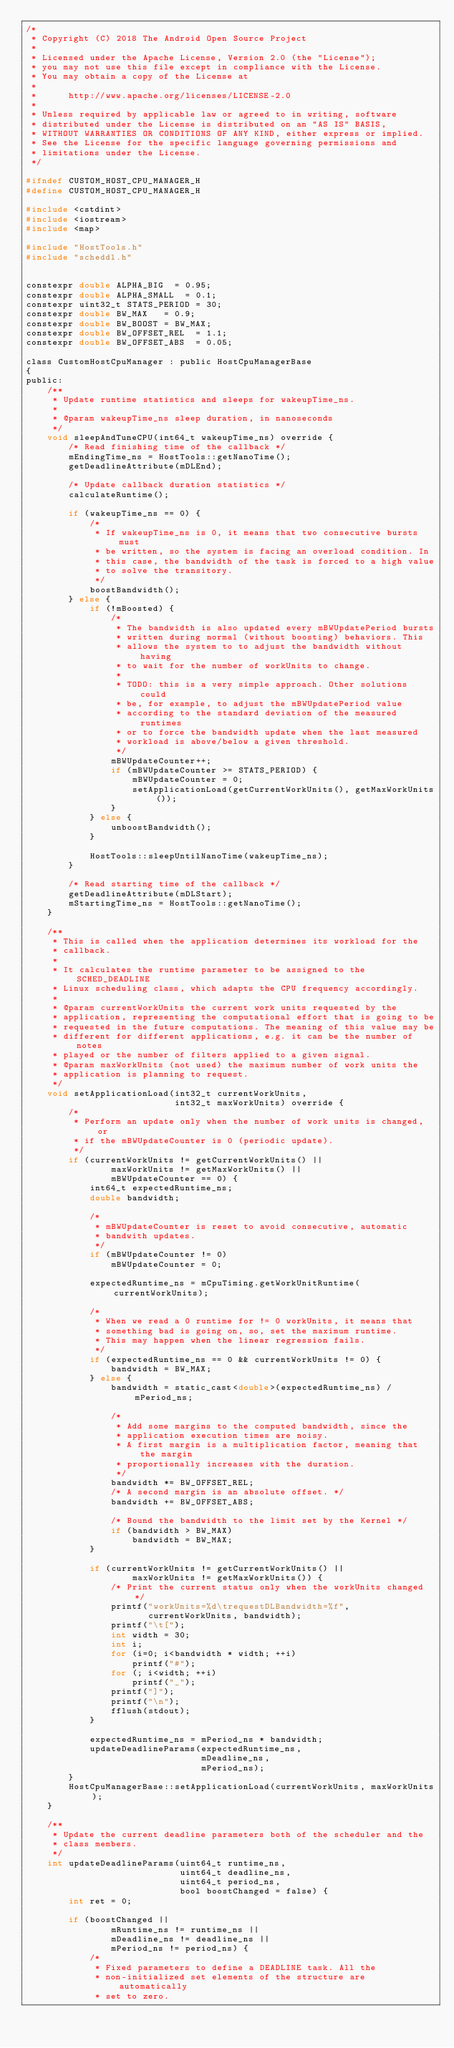Convert code to text. <code><loc_0><loc_0><loc_500><loc_500><_C_>/*
 * Copyright (C) 2018 The Android Open Source Project
 *
 * Licensed under the Apache License, Version 2.0 (the "License");
 * you may not use this file except in compliance with the License.
 * You may obtain a copy of the License at
 *
 *      http://www.apache.org/licenses/LICENSE-2.0
 *
 * Unless required by applicable law or agreed to in writing, software
 * distributed under the License is distributed on an "AS IS" BASIS,
 * WITHOUT WARRANTIES OR CONDITIONS OF ANY KIND, either express or implied.
 * See the License for the specific language governing permissions and
 * limitations under the License.
 */

#ifndef CUSTOM_HOST_CPU_MANAGER_H
#define CUSTOM_HOST_CPU_MANAGER_H

#include <cstdint>
#include <iostream>
#include <map>

#include "HostTools.h"
#include "scheddl.h"


constexpr double ALPHA_BIG	= 0.95;
constexpr double ALPHA_SMALL	= 0.1;
constexpr uint32_t STATS_PERIOD	= 30;
constexpr double BW_MAX		= 0.9;
constexpr double BW_BOOST	= BW_MAX;
constexpr double BW_OFFSET_REL	= 1.1;
constexpr double BW_OFFSET_ABS	= 0.05;

class CustomHostCpuManager : public HostCpuManagerBase
{
public:
    /**
     * Update runtime statistics and sleeps for wakeupTime_ns.
     *
     * @param wakeupTime_ns sleep duration, in nanoseconds
     */
    void sleepAndTuneCPU(int64_t wakeupTime_ns) override {
        /* Read finishing time of the callback */
        mEndingTime_ns = HostTools::getNanoTime();
        getDeadlineAttribute(mDLEnd);

        /* Update callback duration statistics */
        calculateRuntime();

        if (wakeupTime_ns == 0) {
            /*
             * If wakeupTime_ns is 0, it means that two consecutive bursts must
             * be written, so the system is facing an overload condition. In
             * this case, the bandwidth of the task is forced to a high value
             * to solve the transitory.
             */
            boostBandwidth();
        } else {
            if (!mBoosted) {
                /*
                 * The bandwidth is also updated every mBWUpdatePeriod bursts
                 * written during normal (without boosting) behaviors. This
                 * allows the system to to adjust the bandwidth without having
                 * to wait for the number of workUnits to change.
                 *
                 * TODO: this is a very simple approach. Other solutions could
                 * be, for example, to adjust the mBWUpdatePeriod value
                 * according to the standard deviation of the measured runtimes
                 * or to force the bandwidth update when the last measured
                 * workload is above/below a given threshold.
                 */
                mBWUpdateCounter++;
                if (mBWUpdateCounter >= STATS_PERIOD) {
                    mBWUpdateCounter = 0;
                    setApplicationLoad(getCurrentWorkUnits(), getMaxWorkUnits());
                }
            } else {
                unboostBandwidth();
            }

            HostTools::sleepUntilNanoTime(wakeupTime_ns);
        }

        /* Read starting time of the callback */
        getDeadlineAttribute(mDLStart);
        mStartingTime_ns = HostTools::getNanoTime();
    }

    /**
     * This is called when the application determines its workload for the
     * callback.
     *
     * It calculates the runtime parameter to be assigned to the SCHED_DEADLINE
     * Linux scheduling class, which adapts the CPU frequency accordingly.
     *
     * @param currentWorkUnits the current work units requested by the
     * application, representing the computational effort that is going to be
     * requested in the future computations. The meaning of this value may be
     * different for different applications, e.g. it can be the number of notes
     * played or the number of filters applied to a given signal.
     * @param maxWorkUnits (not used) the maximum number of work units the
     * application is planning to request.
     */
    void setApplicationLoad(int32_t currentWorkUnits,
                            int32_t maxWorkUnits) override {
        /*
         * Perform an update only when the number of work units is changed, or
         * if the mBWUpdateCounter is 0 (periodic update).
         */
        if (currentWorkUnits != getCurrentWorkUnits() ||
                maxWorkUnits != getMaxWorkUnits() ||
                mBWUpdateCounter == 0) {
            int64_t expectedRuntime_ns;
            double bandwidth;

            /*
             * mBWUpdateCounter is reset to avoid consecutive, automatic
             * bandwith updates.
             */
            if (mBWUpdateCounter != 0)
                mBWUpdateCounter = 0;

            expectedRuntime_ns = mCpuTiming.getWorkUnitRuntime(currentWorkUnits);

            /*
             * When we read a 0 runtime for != 0 workUnits, it means that
             * something bad is going on, so, set the maximum runtime.
             * This may happen when the linear regression fails.
             */
            if (expectedRuntime_ns == 0 && currentWorkUnits != 0) {
                bandwidth = BW_MAX;
            } else {
                bandwidth = static_cast<double>(expectedRuntime_ns) / mPeriod_ns;

                /*
                 * Add some margins to the computed bandwidth, since the
                 * application execution times are noisy.
                 * A first margin is a multiplication factor, meaning that the margin
                 * proportionally increases with the duration.
                 */ 
                bandwidth *= BW_OFFSET_REL;
                /* A second margin is an absolute offset. */
                bandwidth += BW_OFFSET_ABS;

                /* Bound the bandwidth to the limit set by the Kernel */
                if (bandwidth > BW_MAX)
                    bandwidth = BW_MAX;
            }

            if (currentWorkUnits != getCurrentWorkUnits() ||
                    maxWorkUnits != getMaxWorkUnits()) {
                /* Print the current status only when the workUnits changed */
                printf("workUnits=%d\trequestDLBandwidth=%f",
                       currentWorkUnits, bandwidth);
                printf("\t[");
                int width = 30;
                int i;
                for (i=0; i<bandwidth * width; ++i)
                    printf("#");
                for (; i<width; ++i)
                    printf("_");
                printf("]");
                printf("\n");
                fflush(stdout);
            }

            expectedRuntime_ns = mPeriod_ns * bandwidth;
            updateDeadlineParams(expectedRuntime_ns,
                                 mDeadline_ns,
                                 mPeriod_ns);
        }
        HostCpuManagerBase::setApplicationLoad(currentWorkUnits, maxWorkUnits);
    }

    /**
     * Update the current deadline parameters both of the scheduler and the
     * class members.
     */
    int updateDeadlineParams(uint64_t runtime_ns,
                             uint64_t deadline_ns,
                             uint64_t period_ns,
                             bool boostChanged = false) {
        int ret = 0;

        if (boostChanged ||
                mRuntime_ns != runtime_ns ||
                mDeadline_ns != deadline_ns ||
                mPeriod_ns != period_ns) {
            /*
             * Fixed parameters to define a DEADLINE task. All the
             * non-initialized set elements of the structure are automatically
             * set to zero.</code> 